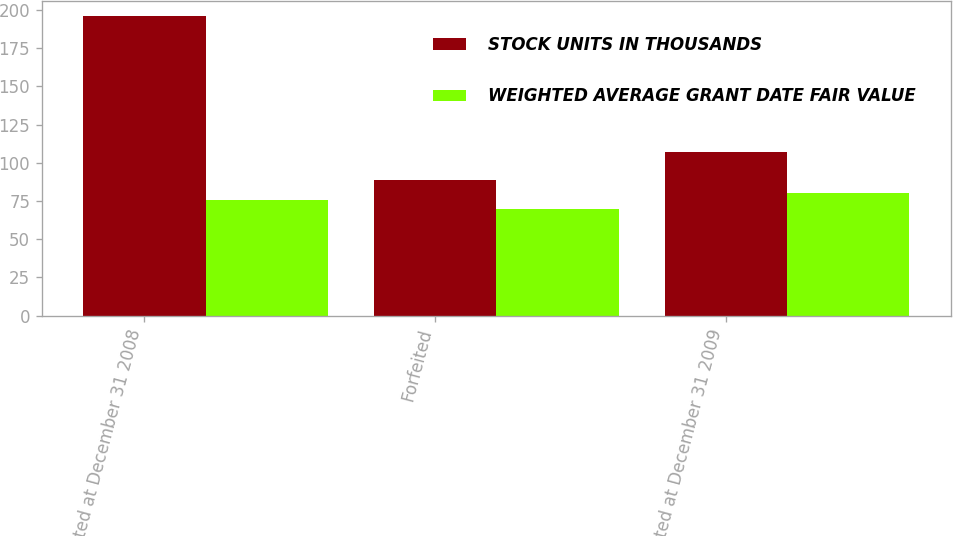<chart> <loc_0><loc_0><loc_500><loc_500><stacked_bar_chart><ecel><fcel>Nonvested at December 31 2008<fcel>Forfeited<fcel>Nonvested at December 31 2009<nl><fcel>STOCK UNITS IN THOUSANDS<fcel>196<fcel>89<fcel>107<nl><fcel>WEIGHTED AVERAGE GRANT DATE FAIR VALUE<fcel>75.35<fcel>69.59<fcel>80.12<nl></chart> 